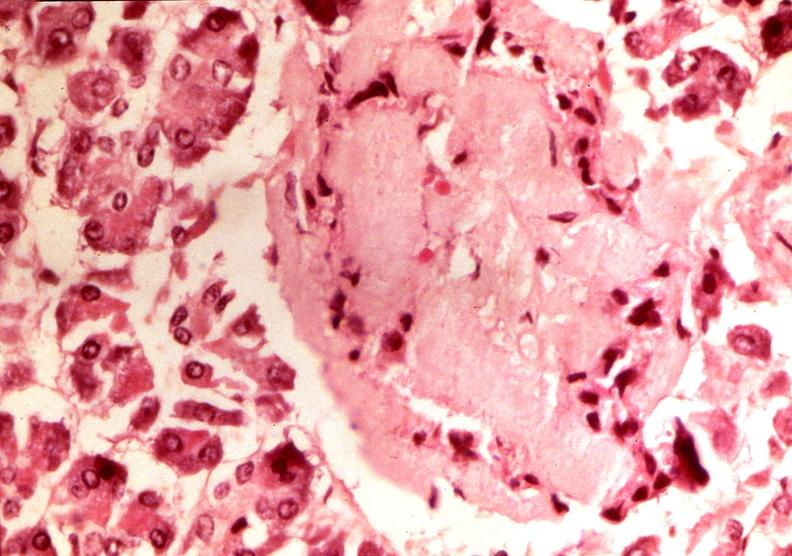s endocrine present?
Answer the question using a single word or phrase. Yes 